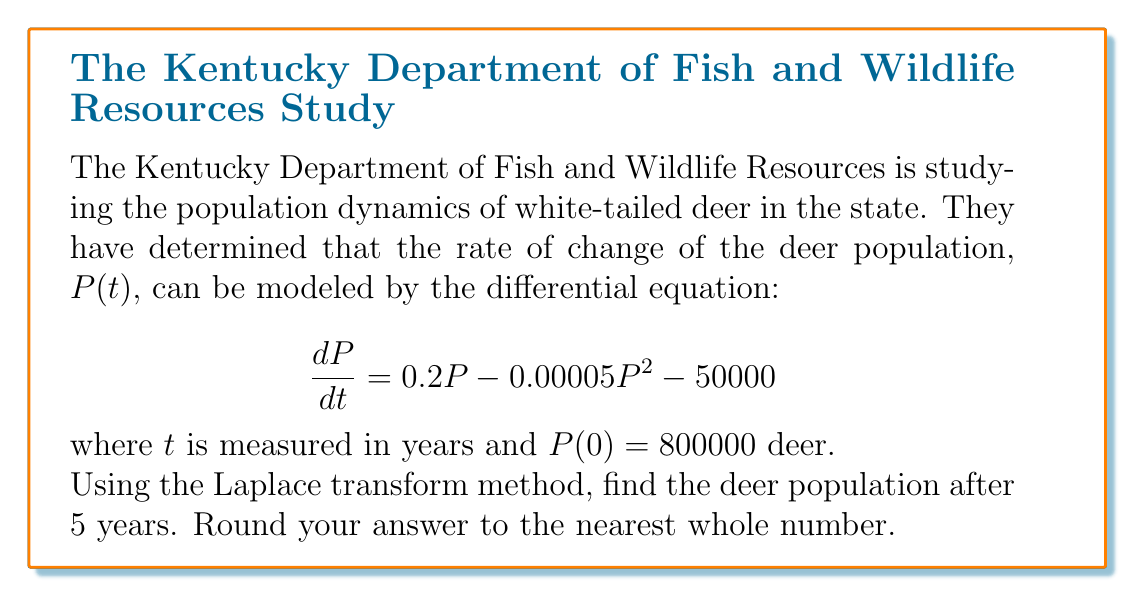Give your solution to this math problem. Let's solve this step-by-step using the Laplace transform method:

1) First, we take the Laplace transform of both sides of the equation:

   $$\mathcal{L}\left\{\frac{dP}{dt}\right\} = \mathcal{L}\{0.2P - 0.00005P^2 - 50000\}$$

2) Using the linearity property and the fact that $\mathcal{L}\{c\} = \frac{c}{s}$ for a constant $c$:

   $$s\mathcal{L}\{P\} - P(0) = 0.2\mathcal{L}\{P\} - 0.00005\mathcal{L}\{P^2\} - \frac{50000}{s}$$

3) Let $\mathcal{L}\{P\} = F(s)$. Then:

   $$sF(s) - 800000 = 0.2F(s) - 0.00005\mathcal{L}\{P^2\} - \frac{50000}{s}$$

4) The term $\mathcal{L}\{P^2\}$ makes this a non-linear problem, which is difficult to solve analytically. We need to make an approximation.

5) Let's assume that the quadratic term is small compared to the linear term. This is reasonable if $P$ doesn't get too large. We'll neglect this term:

   $$sF(s) - 800000 \approx 0.2F(s) - \frac{50000}{s}$$

6) Rearranging:

   $$(s - 0.2)F(s) = 800000 + \frac{50000}{s}$$

7) Solving for $F(s)$:

   $$F(s) = \frac{800000}{s - 0.2} + \frac{50000}{s(s - 0.2)}$$

8) This can be inverse transformed using partial fraction decomposition:

   $$P(t) \approx 800000e^{0.2t} + 250000(1 - e^{0.2t})$$

9) Evaluating at $t = 5$:

   $$P(5) \approx 800000e^{1} + 250000(1 - e^{1}) \approx 1943509$$

10) Rounding to the nearest whole number:

    $$P(5) \approx 1943509$$
Answer: 1943509 deer 